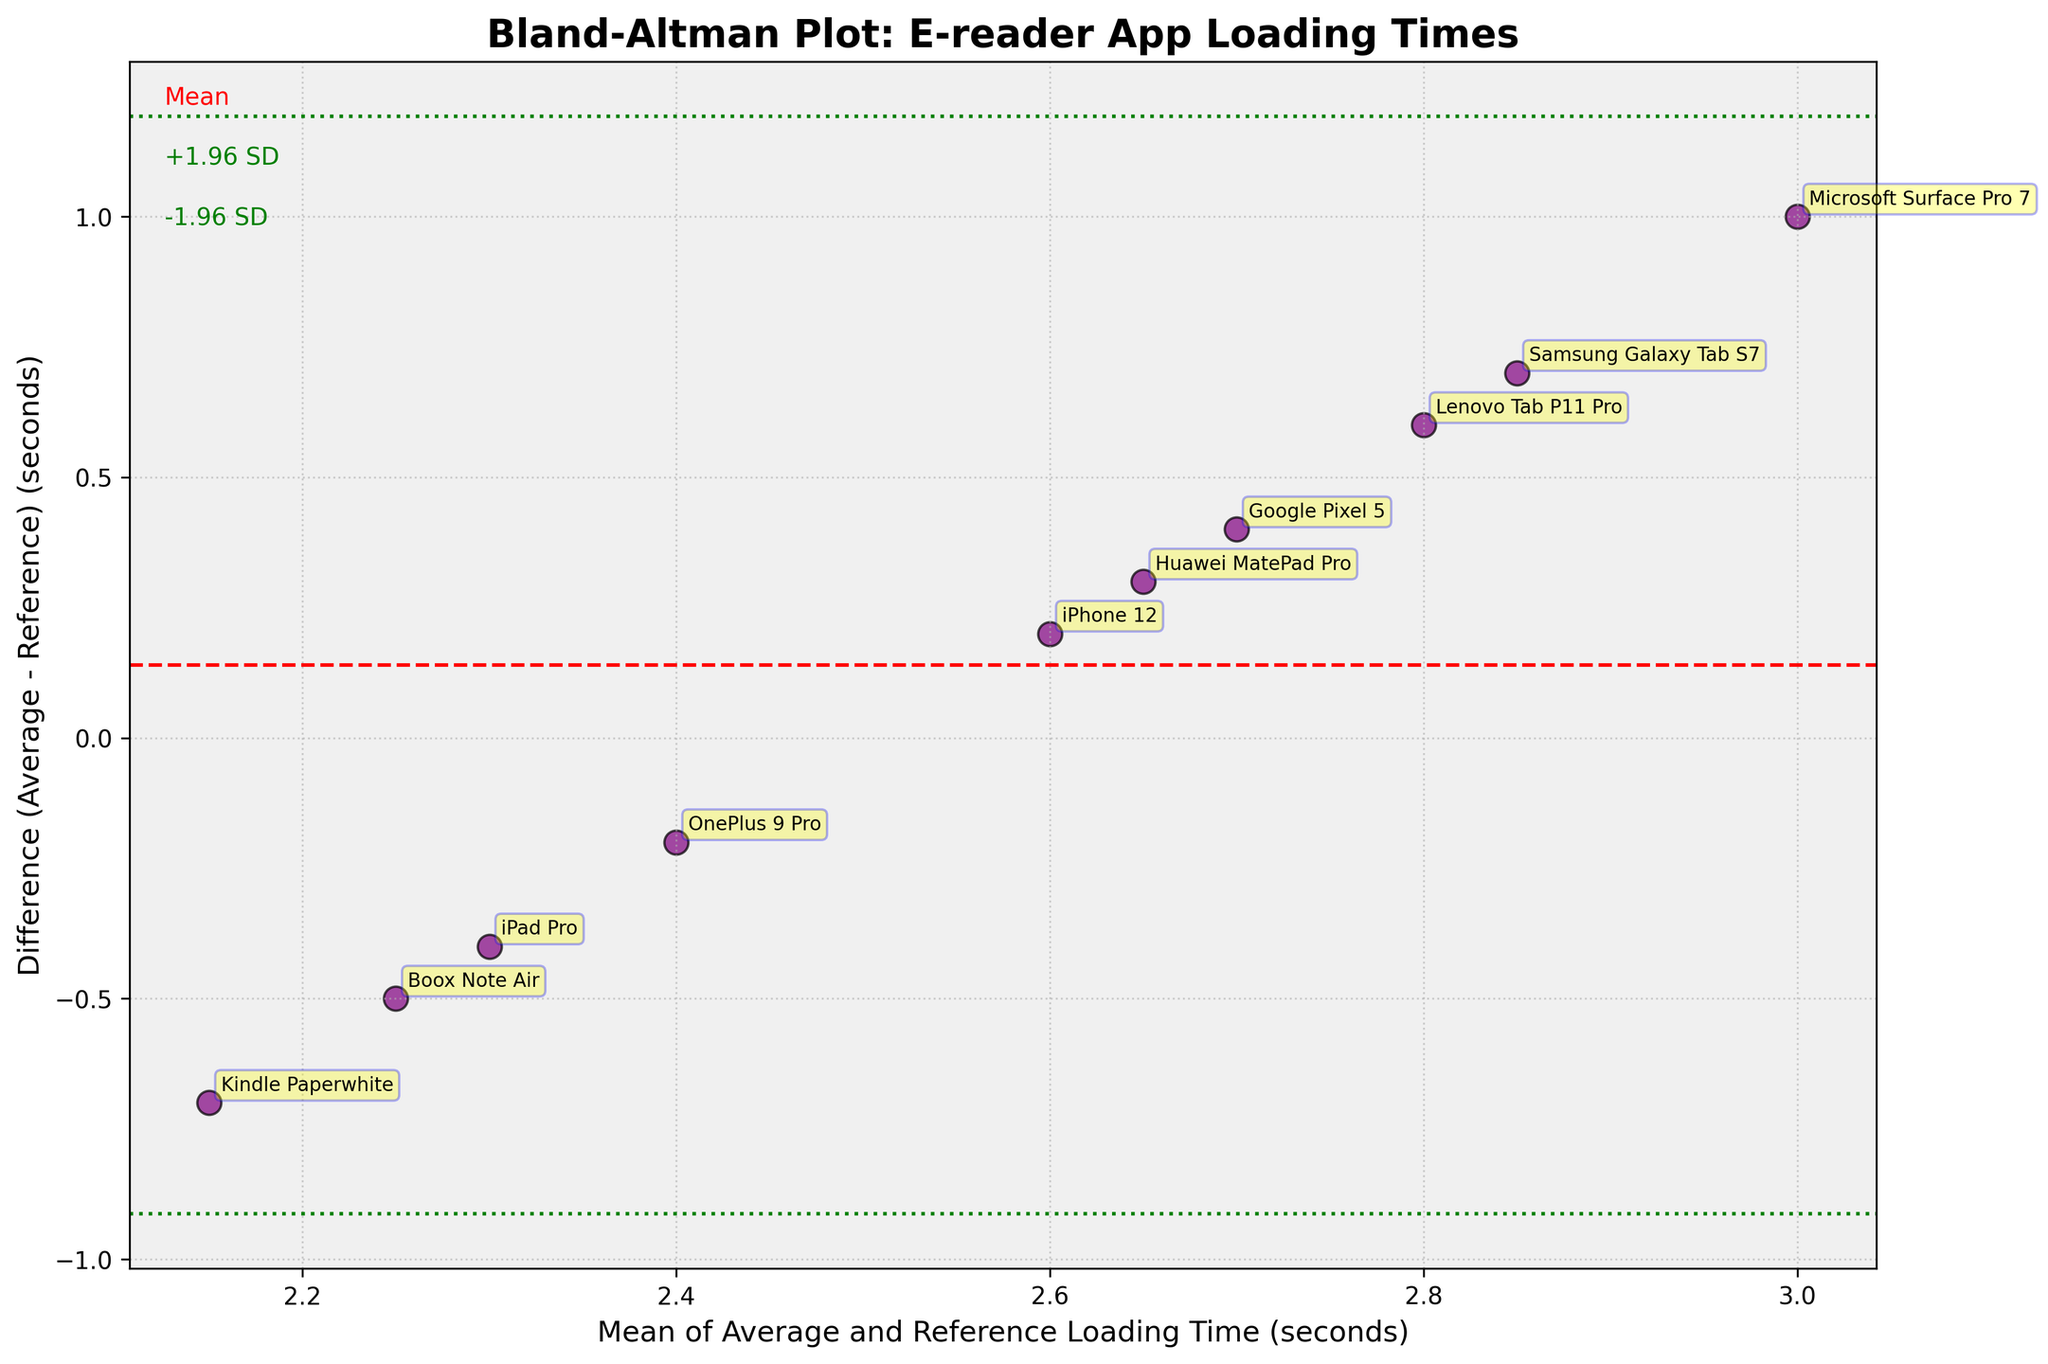What is the title of the plot? The title of the plot is written at the top in bold and larger font.
Answer: Bland-Altman Plot: E-reader App Loading Times How many data points are there in the plot? We count the distinct scatter points representing different devices.
Answer: 10 What are the colors of the horizontal lines on the plot? There are three horizontal lines with different styles and colors: one dashed line in red and two dotted lines in green.
Answer: Red and Green Which device has the largest positive difference in loading times? We find the point that is highest above the x-axis.
Answer: Microsoft Surface Pro 7 What is the mean difference of the loading times? The mean difference is represented by the red dashed line, clearly labeled 'Mean' in the plot.
Answer: 0 Which device has a loading time closest to the mean difference? We locate the point closest to the red dashed mean line.
Answer: iPhone 12 What are the approximate values of the limits of agreement? The limits of agreement are indicated by the green dotted lines, labeled as '+1.96 SD' and '-1.96 SD'.
Answer: +1.96 SD: ~1.8, -1.96 SD: ~-1.8 Which device has the most negative difference in loading times? We find the point that is lowest below the x-axis.
Answer: Kindle Paperwhite What does the position of the devices on the y-axis indicate in the Bland–Altman plot? The y-axis shows the difference between the average and reference loading times for each device. Devices above the x-axis had higher average loading times compared to the reference, while those below had lower average loading times.
Answer: Difference in loading times Which devices have negative differences in loading times? By searching below the x-axis, we find all points representing devices with negative differences.
Answer: iPad Pro, Kindle Paperwhite, Boox Note Air, OnePlus 9 Pro 